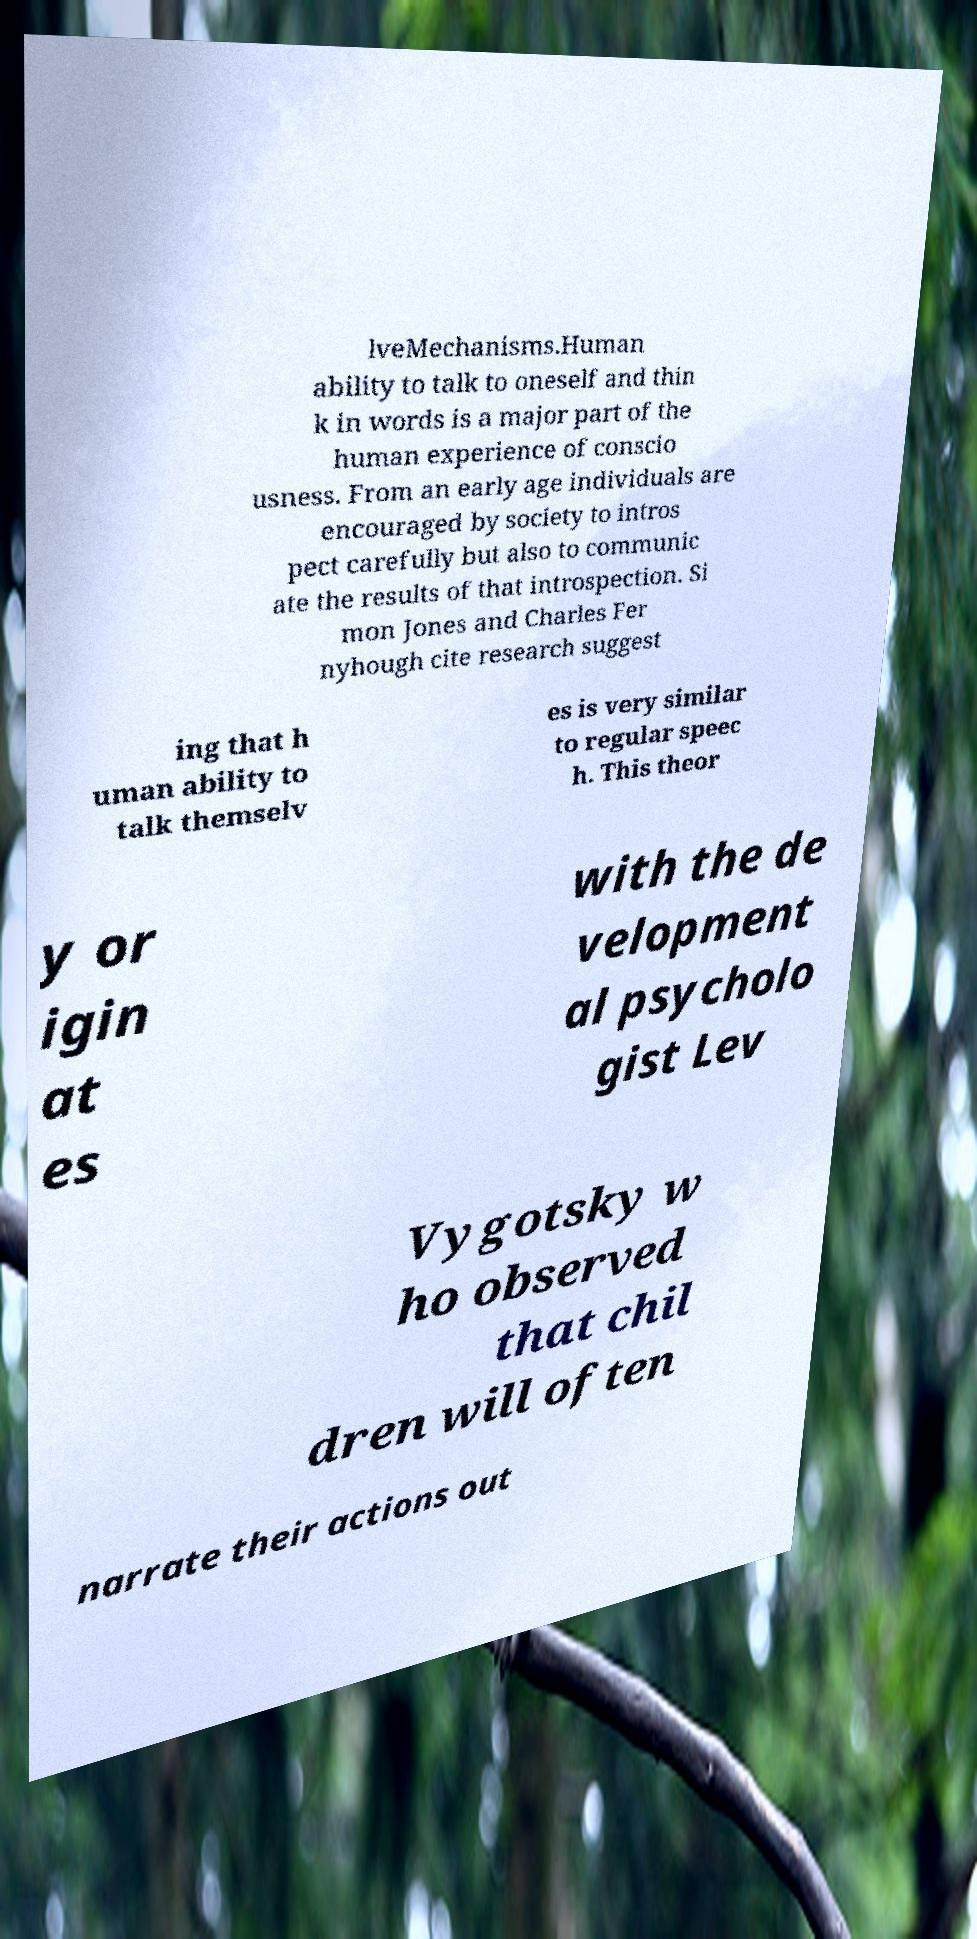Please identify and transcribe the text found in this image. lveMechanisms.Human ability to talk to oneself and thin k in words is a major part of the human experience of conscio usness. From an early age individuals are encouraged by society to intros pect carefully but also to communic ate the results of that introspection. Si mon Jones and Charles Fer nyhough cite research suggest ing that h uman ability to talk themselv es is very similar to regular speec h. This theor y or igin at es with the de velopment al psycholo gist Lev Vygotsky w ho observed that chil dren will often narrate their actions out 